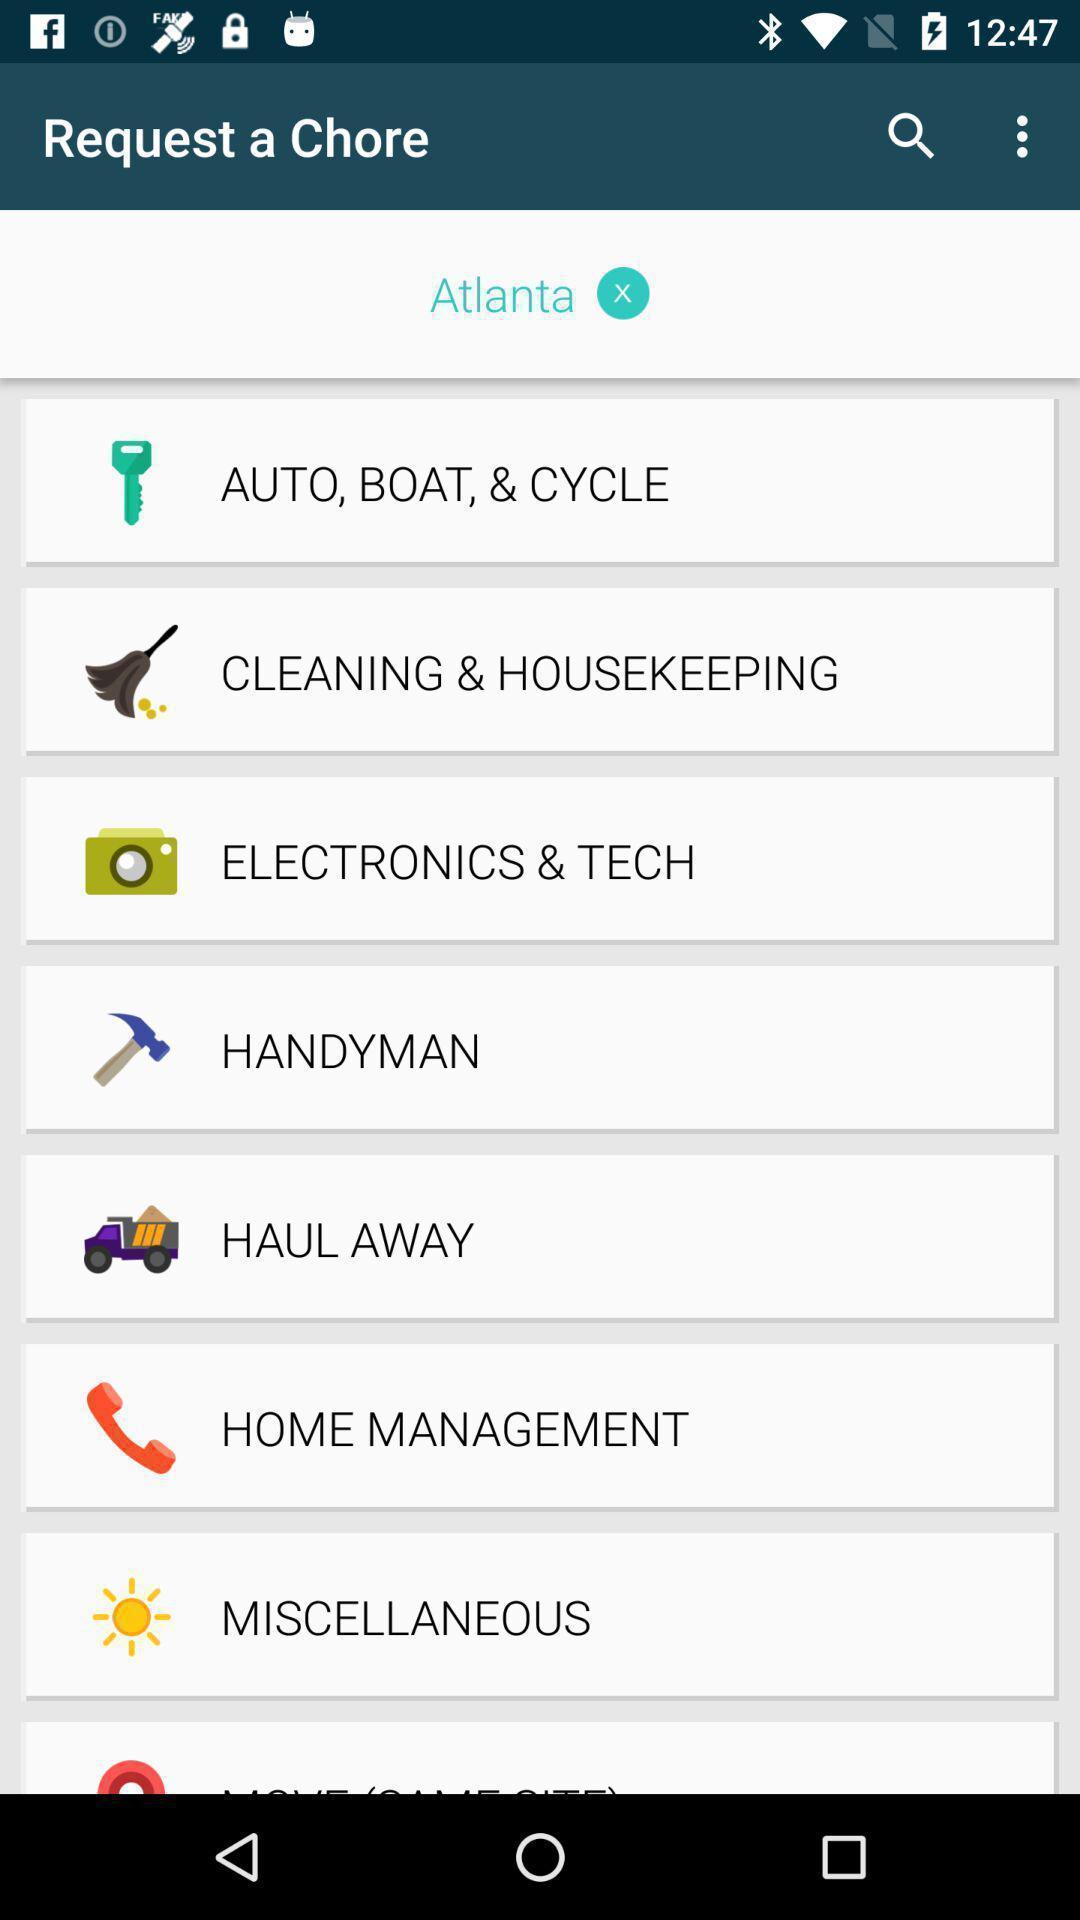What can you discern from this picture? Page showing various options on app. 